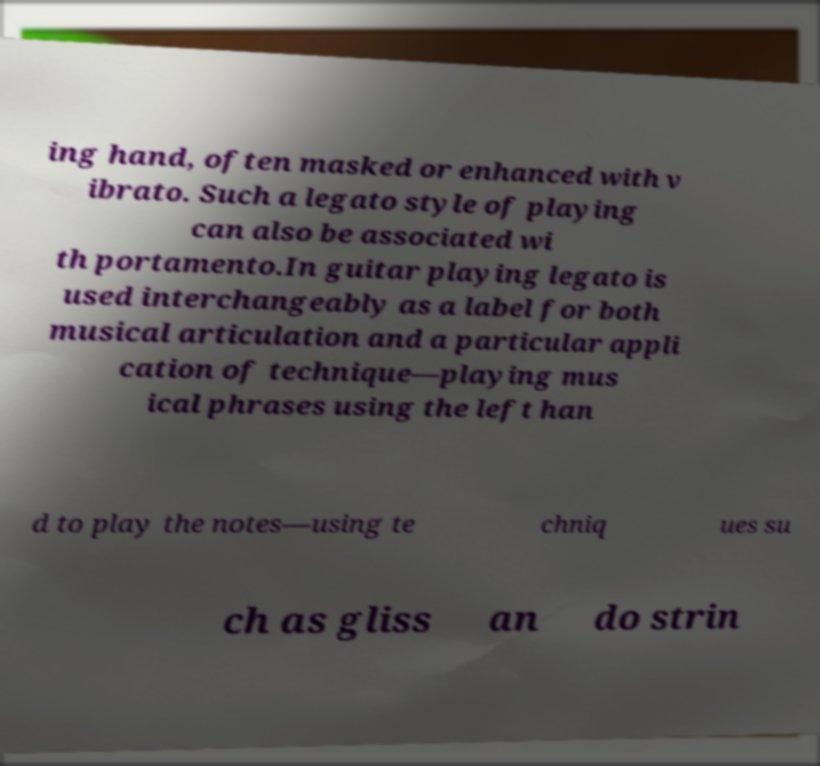Could you assist in decoding the text presented in this image and type it out clearly? ing hand, often masked or enhanced with v ibrato. Such a legato style of playing can also be associated wi th portamento.In guitar playing legato is used interchangeably as a label for both musical articulation and a particular appli cation of technique—playing mus ical phrases using the left han d to play the notes—using te chniq ues su ch as gliss an do strin 